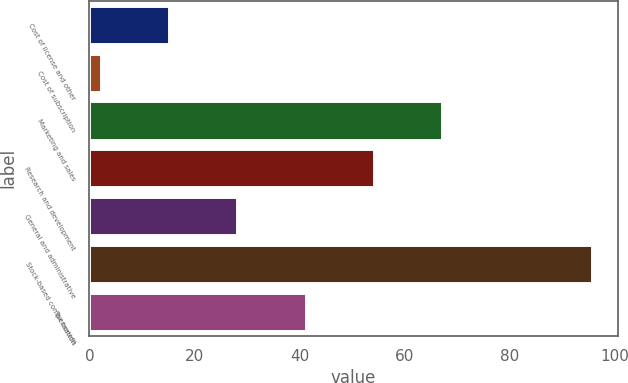Convert chart to OTSL. <chart><loc_0><loc_0><loc_500><loc_500><bar_chart><fcel>Cost of license and other<fcel>Cost of subscription<fcel>Marketing and sales<fcel>Research and development<fcel>General and administrative<fcel>Stock-based compensation<fcel>Tax benefit<nl><fcel>15.2<fcel>2.2<fcel>67.2<fcel>54.2<fcel>28.2<fcel>95.8<fcel>41.2<nl></chart> 